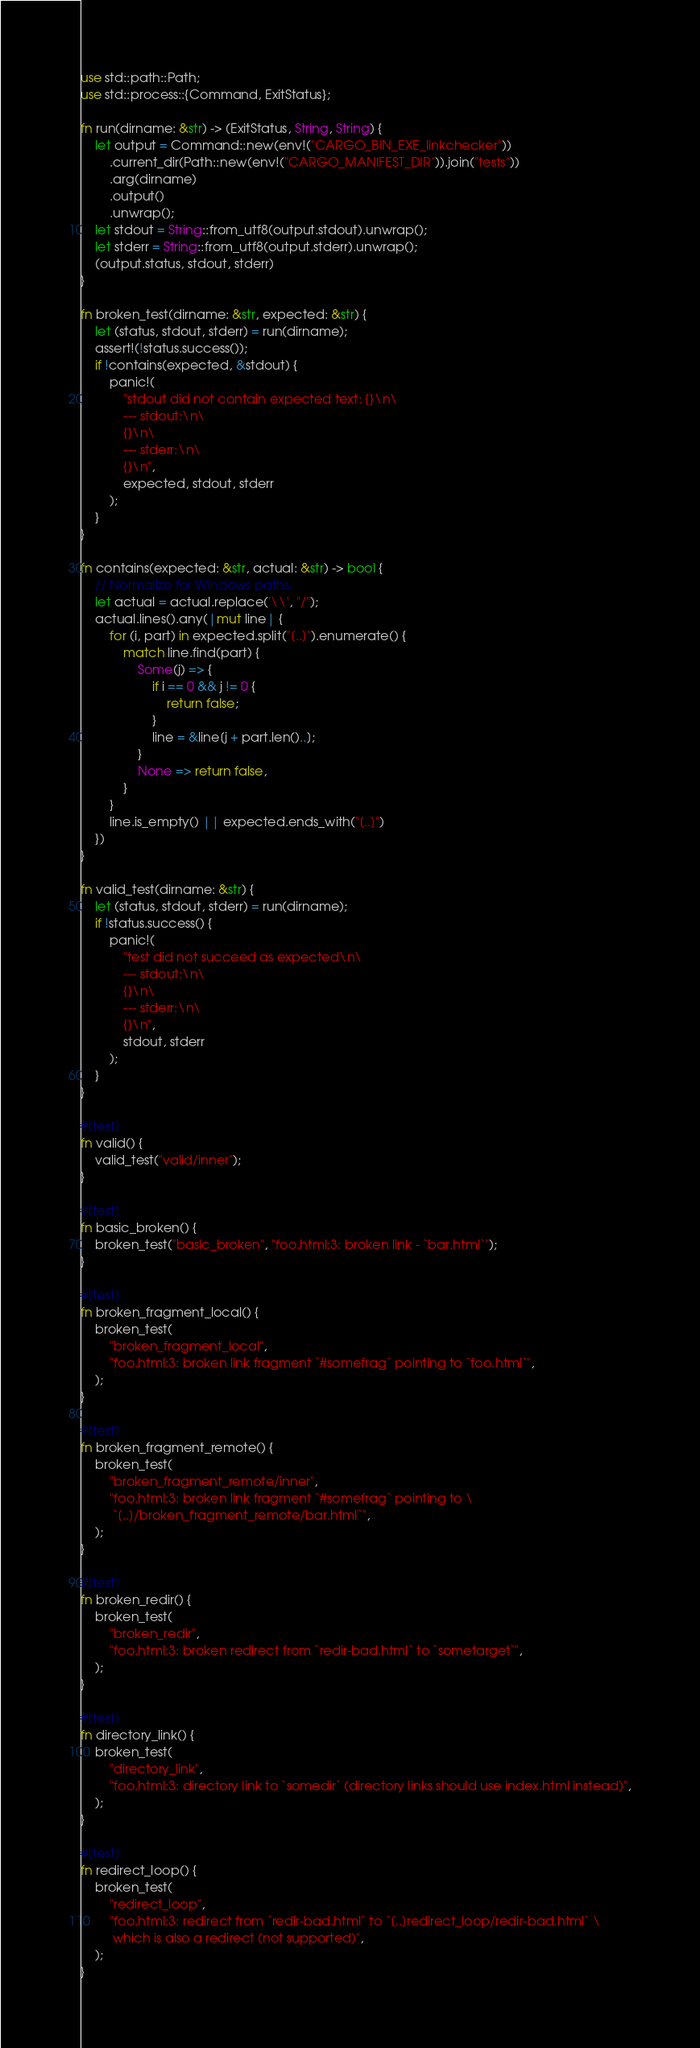<code> <loc_0><loc_0><loc_500><loc_500><_Rust_>use std::path::Path;
use std::process::{Command, ExitStatus};

fn run(dirname: &str) -> (ExitStatus, String, String) {
    let output = Command::new(env!("CARGO_BIN_EXE_linkchecker"))
        .current_dir(Path::new(env!("CARGO_MANIFEST_DIR")).join("tests"))
        .arg(dirname)
        .output()
        .unwrap();
    let stdout = String::from_utf8(output.stdout).unwrap();
    let stderr = String::from_utf8(output.stderr).unwrap();
    (output.status, stdout, stderr)
}

fn broken_test(dirname: &str, expected: &str) {
    let (status, stdout, stderr) = run(dirname);
    assert!(!status.success());
    if !contains(expected, &stdout) {
        panic!(
            "stdout did not contain expected text: {}\n\
            --- stdout:\n\
            {}\n\
            --- stderr:\n\
            {}\n",
            expected, stdout, stderr
        );
    }
}

fn contains(expected: &str, actual: &str) -> bool {
    // Normalize for Windows paths.
    let actual = actual.replace('\\', "/");
    actual.lines().any(|mut line| {
        for (i, part) in expected.split("[..]").enumerate() {
            match line.find(part) {
                Some(j) => {
                    if i == 0 && j != 0 {
                        return false;
                    }
                    line = &line[j + part.len()..];
                }
                None => return false,
            }
        }
        line.is_empty() || expected.ends_with("[..]")
    })
}

fn valid_test(dirname: &str) {
    let (status, stdout, stderr) = run(dirname);
    if !status.success() {
        panic!(
            "test did not succeed as expected\n\
            --- stdout:\n\
            {}\n\
            --- stderr:\n\
            {}\n",
            stdout, stderr
        );
    }
}

#[test]
fn valid() {
    valid_test("valid/inner");
}

#[test]
fn basic_broken() {
    broken_test("basic_broken", "foo.html:3: broken link - `bar.html`");
}

#[test]
fn broken_fragment_local() {
    broken_test(
        "broken_fragment_local",
        "foo.html:3: broken link fragment `#somefrag` pointing to `foo.html`",
    );
}

#[test]
fn broken_fragment_remote() {
    broken_test(
        "broken_fragment_remote/inner",
        "foo.html:3: broken link fragment `#somefrag` pointing to \
         `[..]/broken_fragment_remote/bar.html`",
    );
}

#[test]
fn broken_redir() {
    broken_test(
        "broken_redir",
        "foo.html:3: broken redirect from `redir-bad.html` to `sometarget`",
    );
}

#[test]
fn directory_link() {
    broken_test(
        "directory_link",
        "foo.html:3: directory link to `somedir` (directory links should use index.html instead)",
    );
}

#[test]
fn redirect_loop() {
    broken_test(
        "redirect_loop",
        "foo.html:3: redirect from `redir-bad.html` to `[..]redirect_loop/redir-bad.html` \
         which is also a redirect (not supported)",
    );
}
</code> 